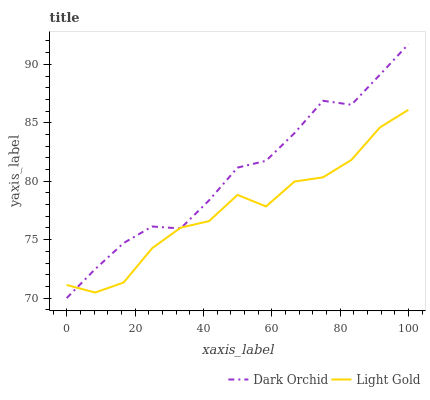Does Dark Orchid have the minimum area under the curve?
Answer yes or no. No. Is Dark Orchid the roughest?
Answer yes or no. No. 